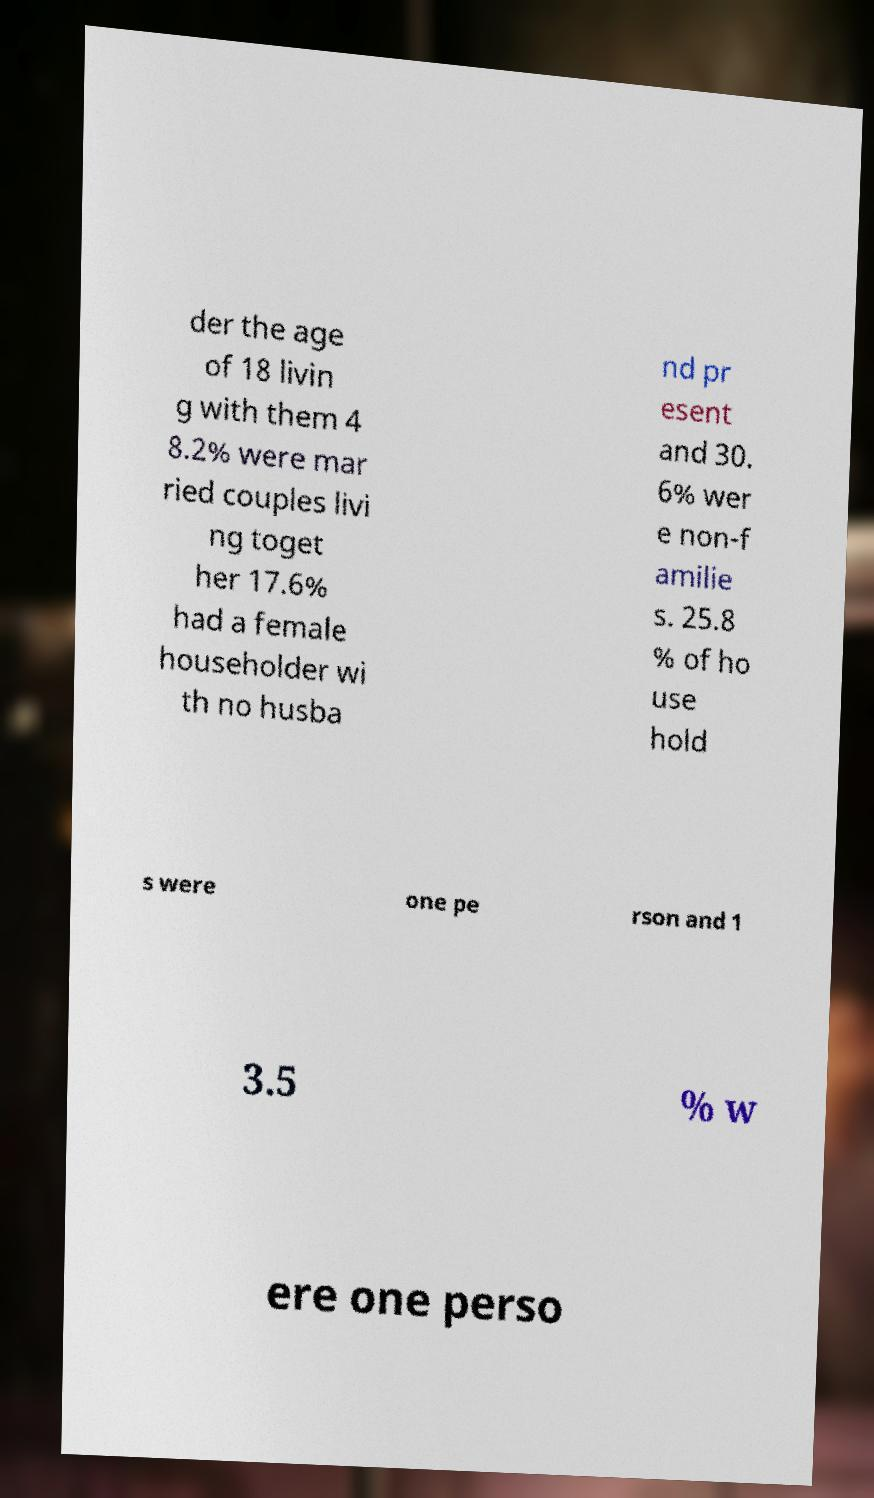Could you extract and type out the text from this image? der the age of 18 livin g with them 4 8.2% were mar ried couples livi ng toget her 17.6% had a female householder wi th no husba nd pr esent and 30. 6% wer e non-f amilie s. 25.8 % of ho use hold s were one pe rson and 1 3.5 % w ere one perso 